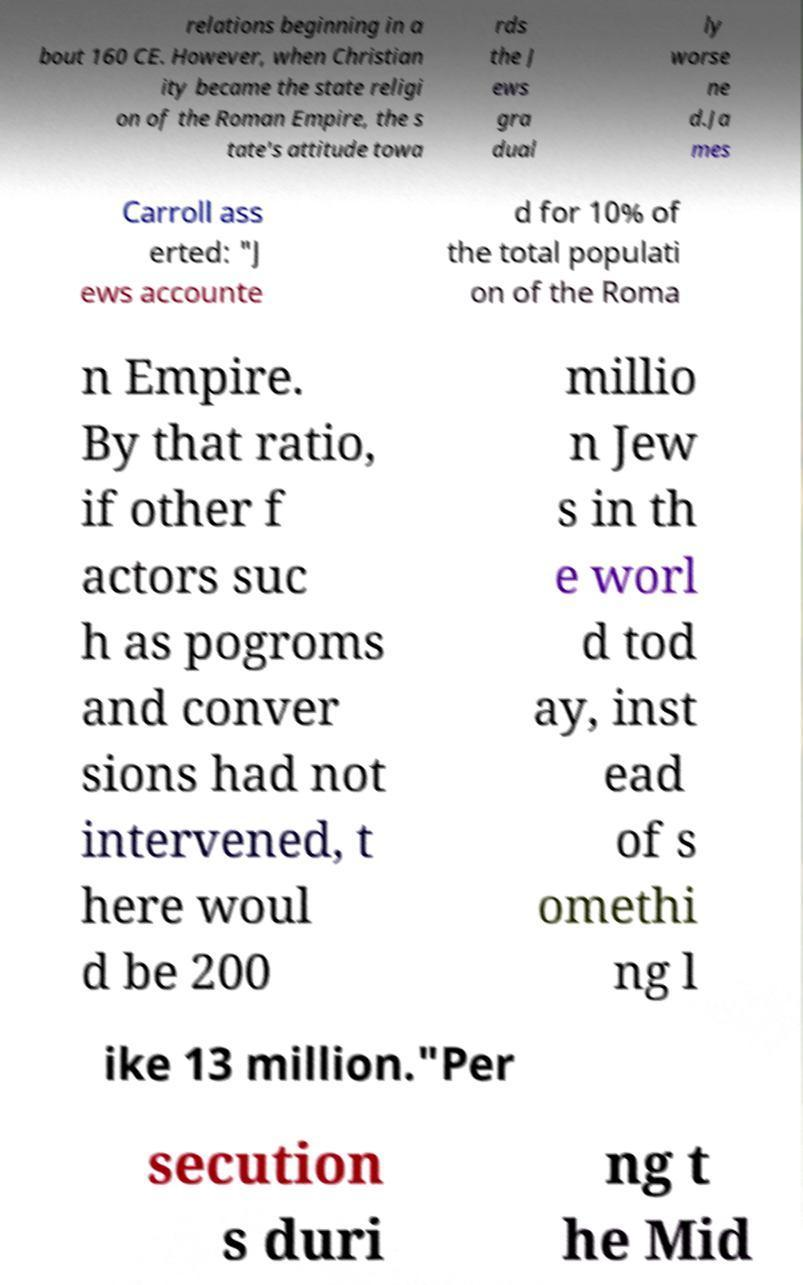I need the written content from this picture converted into text. Can you do that? relations beginning in a bout 160 CE. However, when Christian ity became the state religi on of the Roman Empire, the s tate's attitude towa rds the J ews gra dual ly worse ne d.Ja mes Carroll ass erted: "J ews accounte d for 10% of the total populati on of the Roma n Empire. By that ratio, if other f actors suc h as pogroms and conver sions had not intervened, t here woul d be 200 millio n Jew s in th e worl d tod ay, inst ead of s omethi ng l ike 13 million."Per secution s duri ng t he Mid 